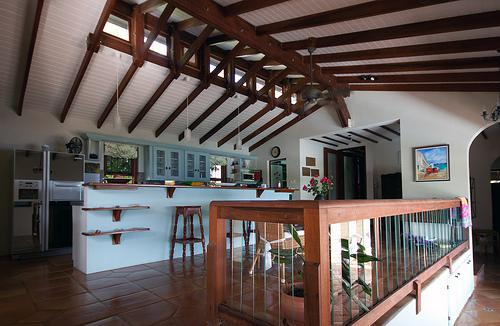Question: what is hanging from the ceiling?
Choices:
A. Lights.
B. Chandelier.
C. Plants.
D. Candle holders.
Answer with the letter. Answer: A Question: where was the photo taken?
Choices:
A. In a bathroom.
B. In a bedroom.
C. In a kitchen.
D. In a den.
Answer with the letter. Answer: C Question: what color is the floor?
Choices:
A. Brown.
B. Blue.
C. Black.
D. Gray.
Answer with the letter. Answer: A 